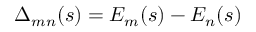<formula> <loc_0><loc_0><loc_500><loc_500>\Delta _ { m n } ( s ) = E _ { m } ( s ) - E _ { n } ( s )</formula> 